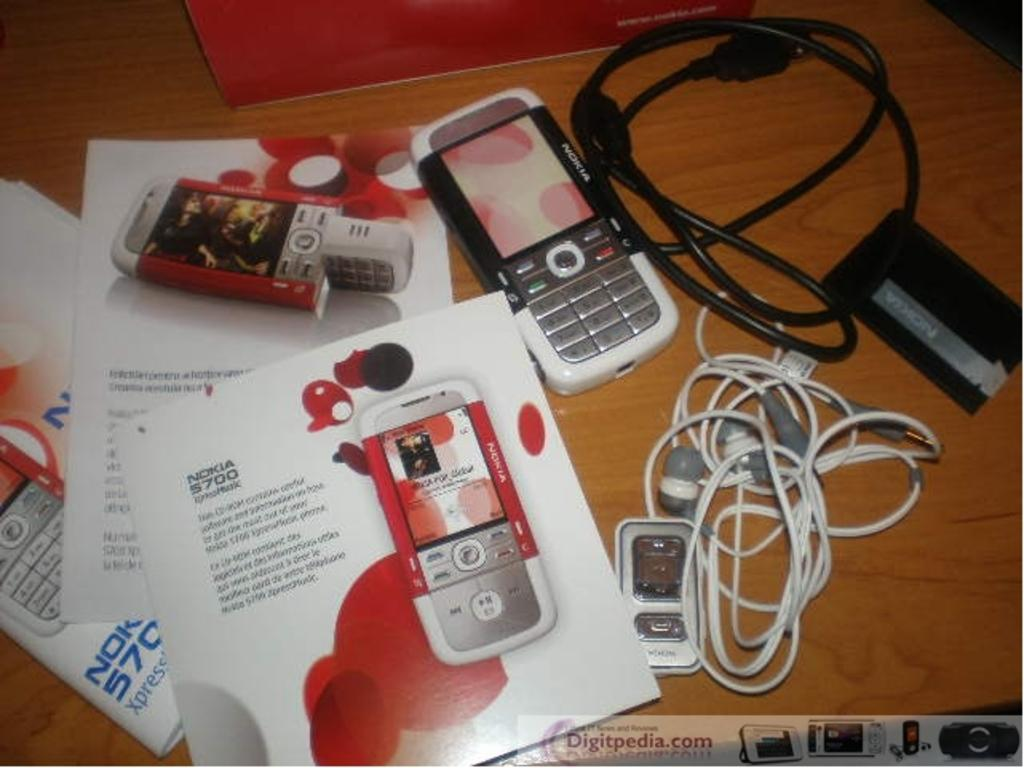<image>
Describe the image concisely. A wooden table with a Nokia 5700 phone and accessories. 